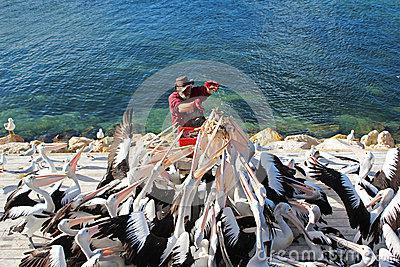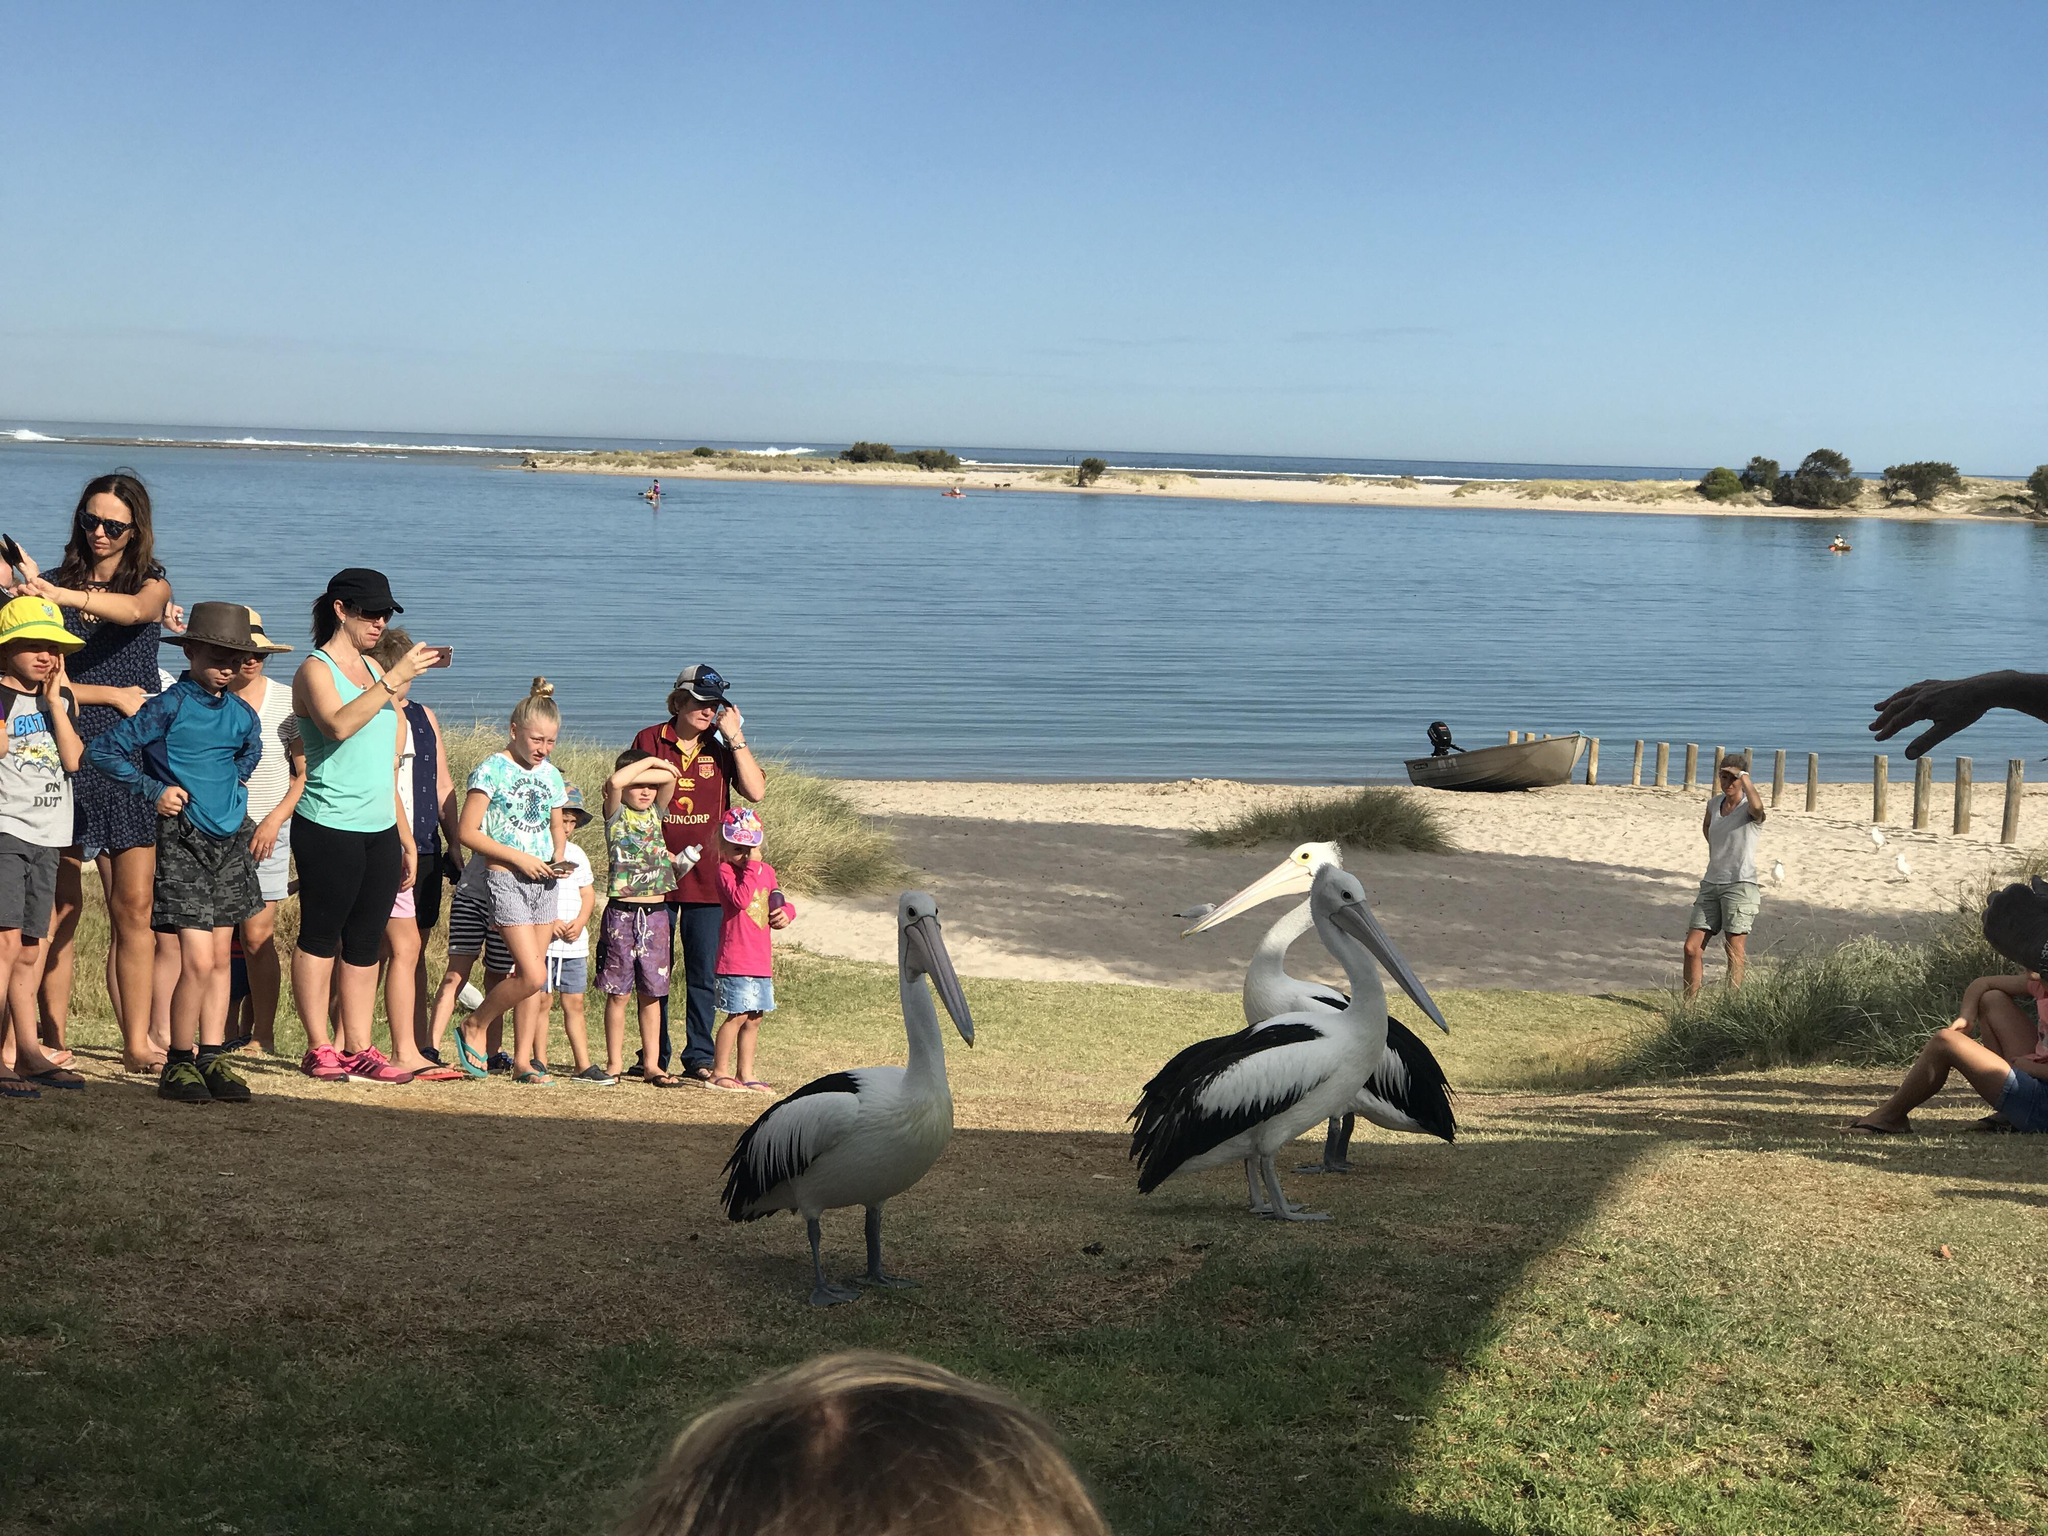The first image is the image on the left, the second image is the image on the right. For the images displayed, is the sentence "There is no more than one bird on a beach in the left image." factually correct? Answer yes or no. No. The first image is the image on the left, the second image is the image on the right. Evaluate the accuracy of this statement regarding the images: "There is a single human feeding a pelican with white and black feathers.". Is it true? Answer yes or no. Yes. 